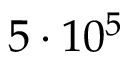<formula> <loc_0><loc_0><loc_500><loc_500>5 \cdot 1 0 ^ { 5 }</formula> 